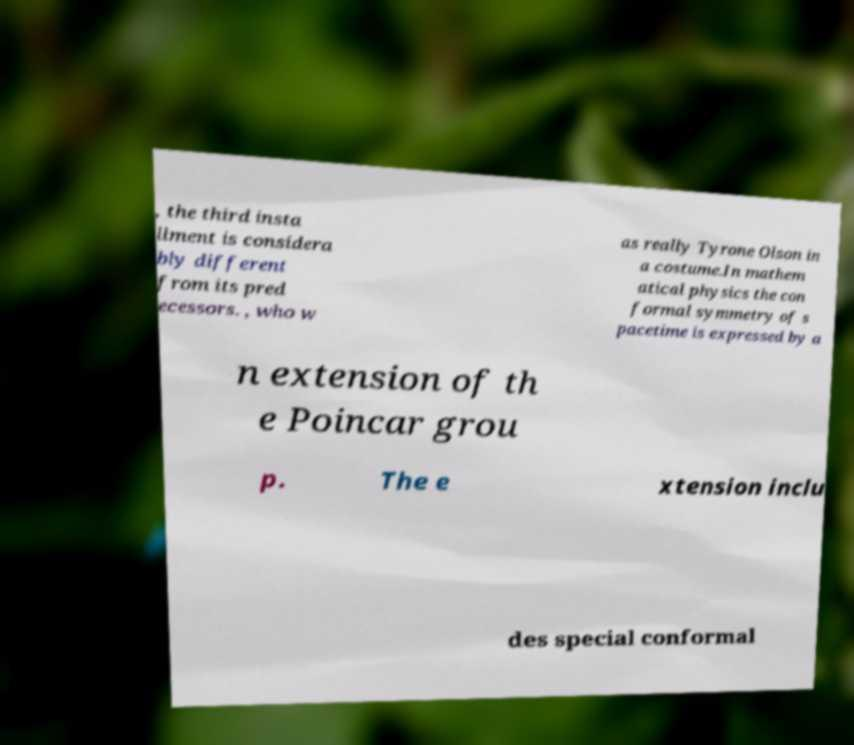Could you extract and type out the text from this image? , the third insta llment is considera bly different from its pred ecessors. , who w as really Tyrone Olson in a costume.In mathem atical physics the con formal symmetry of s pacetime is expressed by a n extension of th e Poincar grou p. The e xtension inclu des special conformal 